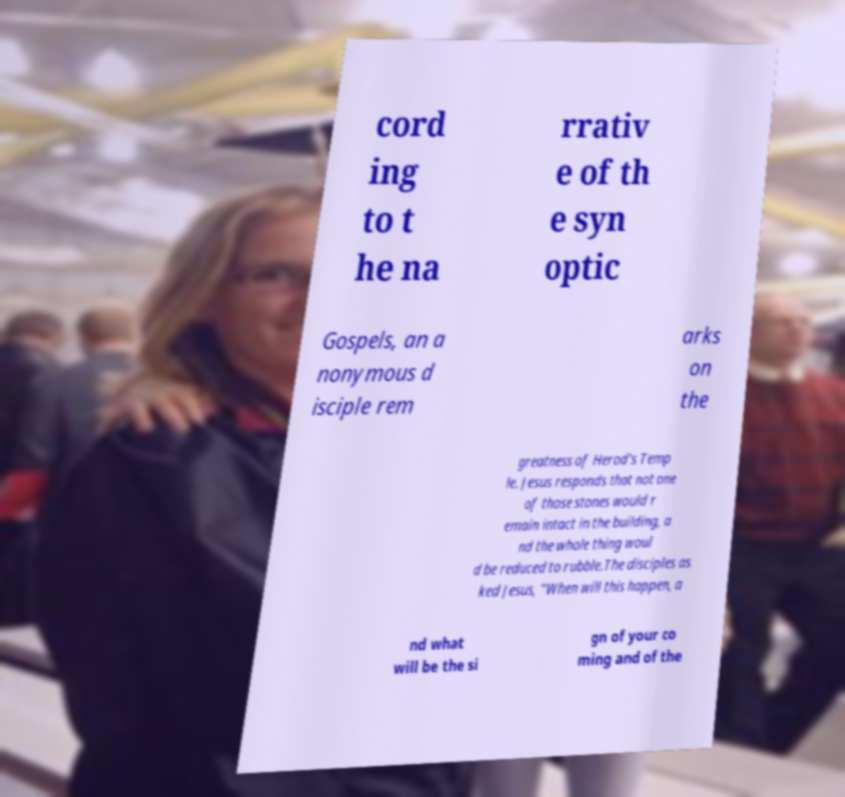Could you extract and type out the text from this image? cord ing to t he na rrativ e of th e syn optic Gospels, an a nonymous d isciple rem arks on the greatness of Herod's Temp le. Jesus responds that not one of those stones would r emain intact in the building, a nd the whole thing woul d be reduced to rubble.The disciples as ked Jesus, "When will this happen, a nd what will be the si gn of your co ming and of the 